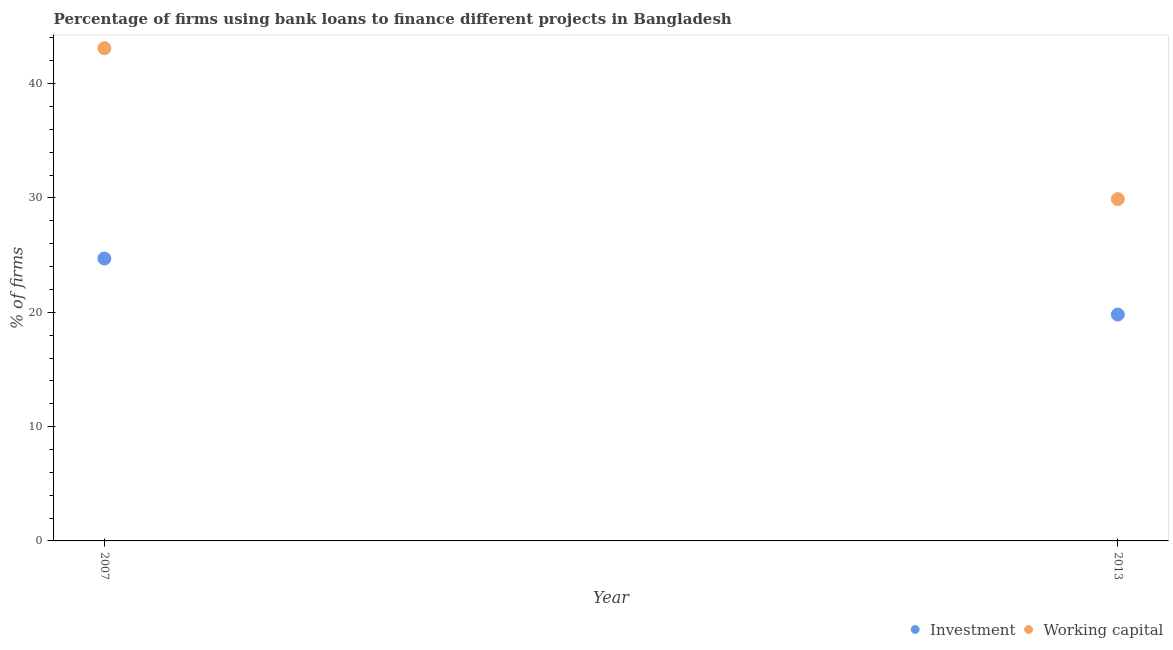How many different coloured dotlines are there?
Your response must be concise. 2. Is the number of dotlines equal to the number of legend labels?
Provide a succinct answer. Yes. What is the percentage of firms using banks to finance investment in 2007?
Offer a very short reply. 24.7. Across all years, what is the maximum percentage of firms using banks to finance investment?
Offer a very short reply. 24.7. Across all years, what is the minimum percentage of firms using banks to finance investment?
Provide a short and direct response. 19.8. In which year was the percentage of firms using banks to finance investment minimum?
Offer a very short reply. 2013. What is the total percentage of firms using banks to finance working capital in the graph?
Provide a succinct answer. 73. What is the difference between the percentage of firms using banks to finance working capital in 2007 and that in 2013?
Your answer should be compact. 13.2. What is the difference between the percentage of firms using banks to finance working capital in 2007 and the percentage of firms using banks to finance investment in 2013?
Give a very brief answer. 23.3. What is the average percentage of firms using banks to finance investment per year?
Offer a terse response. 22.25. In the year 2007, what is the difference between the percentage of firms using banks to finance working capital and percentage of firms using banks to finance investment?
Your response must be concise. 18.4. What is the ratio of the percentage of firms using banks to finance investment in 2007 to that in 2013?
Offer a terse response. 1.25. Is the percentage of firms using banks to finance working capital in 2007 less than that in 2013?
Your response must be concise. No. In how many years, is the percentage of firms using banks to finance investment greater than the average percentage of firms using banks to finance investment taken over all years?
Keep it short and to the point. 1. Is the percentage of firms using banks to finance investment strictly greater than the percentage of firms using banks to finance working capital over the years?
Provide a succinct answer. No. Is the percentage of firms using banks to finance investment strictly less than the percentage of firms using banks to finance working capital over the years?
Your response must be concise. Yes. How many dotlines are there?
Offer a terse response. 2. How many years are there in the graph?
Your answer should be very brief. 2. What is the difference between two consecutive major ticks on the Y-axis?
Your response must be concise. 10. Does the graph contain any zero values?
Offer a very short reply. No. What is the title of the graph?
Provide a succinct answer. Percentage of firms using bank loans to finance different projects in Bangladesh. Does "Largest city" appear as one of the legend labels in the graph?
Provide a succinct answer. No. What is the label or title of the Y-axis?
Ensure brevity in your answer.  % of firms. What is the % of firms of Investment in 2007?
Your answer should be compact. 24.7. What is the % of firms of Working capital in 2007?
Your response must be concise. 43.1. What is the % of firms of Investment in 2013?
Your answer should be compact. 19.8. What is the % of firms of Working capital in 2013?
Make the answer very short. 29.9. Across all years, what is the maximum % of firms in Investment?
Ensure brevity in your answer.  24.7. Across all years, what is the maximum % of firms in Working capital?
Give a very brief answer. 43.1. Across all years, what is the minimum % of firms of Investment?
Offer a very short reply. 19.8. Across all years, what is the minimum % of firms of Working capital?
Your response must be concise. 29.9. What is the total % of firms of Investment in the graph?
Keep it short and to the point. 44.5. What is the difference between the % of firms in Working capital in 2007 and that in 2013?
Your answer should be compact. 13.2. What is the difference between the % of firms in Investment in 2007 and the % of firms in Working capital in 2013?
Your answer should be compact. -5.2. What is the average % of firms in Investment per year?
Offer a terse response. 22.25. What is the average % of firms of Working capital per year?
Make the answer very short. 36.5. In the year 2007, what is the difference between the % of firms in Investment and % of firms in Working capital?
Keep it short and to the point. -18.4. What is the ratio of the % of firms of Investment in 2007 to that in 2013?
Offer a very short reply. 1.25. What is the ratio of the % of firms in Working capital in 2007 to that in 2013?
Keep it short and to the point. 1.44. What is the difference between the highest and the second highest % of firms in Investment?
Your response must be concise. 4.9. What is the difference between the highest and the second highest % of firms in Working capital?
Your answer should be very brief. 13.2. What is the difference between the highest and the lowest % of firms in Working capital?
Keep it short and to the point. 13.2. 